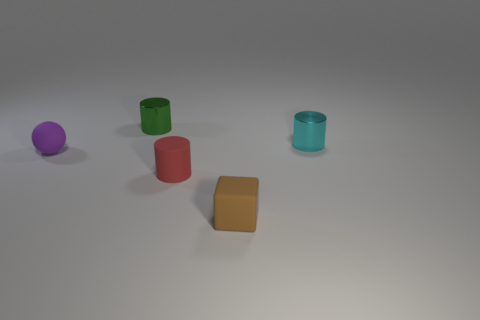Subtract 1 cylinders. How many cylinders are left? 2 Subtract all metal cylinders. How many cylinders are left? 1 Add 3 tiny brown rubber cubes. How many objects exist? 8 Subtract 1 purple balls. How many objects are left? 4 Subtract all cylinders. How many objects are left? 2 Subtract all small green metal objects. Subtract all cyan shiny objects. How many objects are left? 3 Add 3 tiny brown matte cubes. How many tiny brown matte cubes are left? 4 Add 3 brown metal blocks. How many brown metal blocks exist? 3 